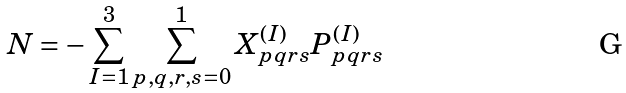Convert formula to latex. <formula><loc_0><loc_0><loc_500><loc_500>N = - \sum _ { I = 1 } ^ { 3 } \sum _ { p , q , r , s = 0 } ^ { 1 } X ^ { ( I ) } _ { p q r s } P _ { p q r s } ^ { ( I ) }</formula> 